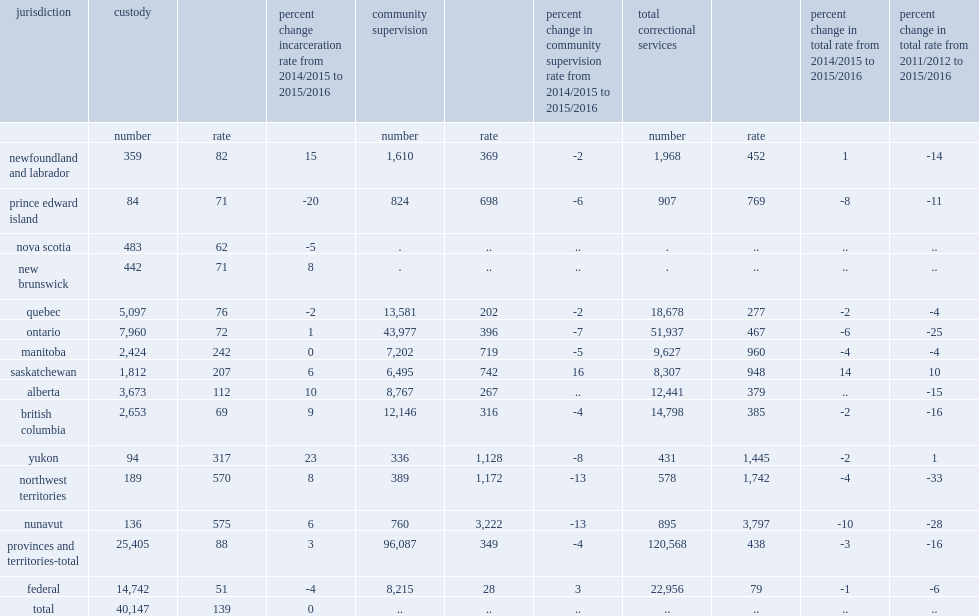In 2015/2016, how many adult offenders on average on a given day, in either custody or in a community program among the 11 reporting provinces and territories for which both custody and community data were available? 120568.0. Between 2011 and 2015, what was the percent of decline in the number of adults charged? 1. On an average day in 2015/2016, how many adults in custody? 40147.0. On an average day in 2015/2016, how many adults in provincial and territorial custody? 25405.0. On an average day in 2015/2016, how many adults in federal custody? 14742.0. How many adult per 100,000 adult population in manitoba? 242.0. How many adults per 100,000 adult population in nova scotia? 62.0. 